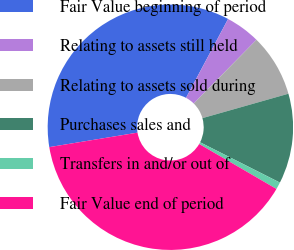Convert chart. <chart><loc_0><loc_0><loc_500><loc_500><pie_chart><fcel>Fair Value beginning of period<fcel>Relating to assets still held<fcel>Relating to assets sold during<fcel>Purchases sales and<fcel>Transfers in and/or out of<fcel>Fair Value end of period<nl><fcel>35.38%<fcel>4.58%<fcel>8.22%<fcel>11.85%<fcel>0.94%<fcel>39.02%<nl></chart> 